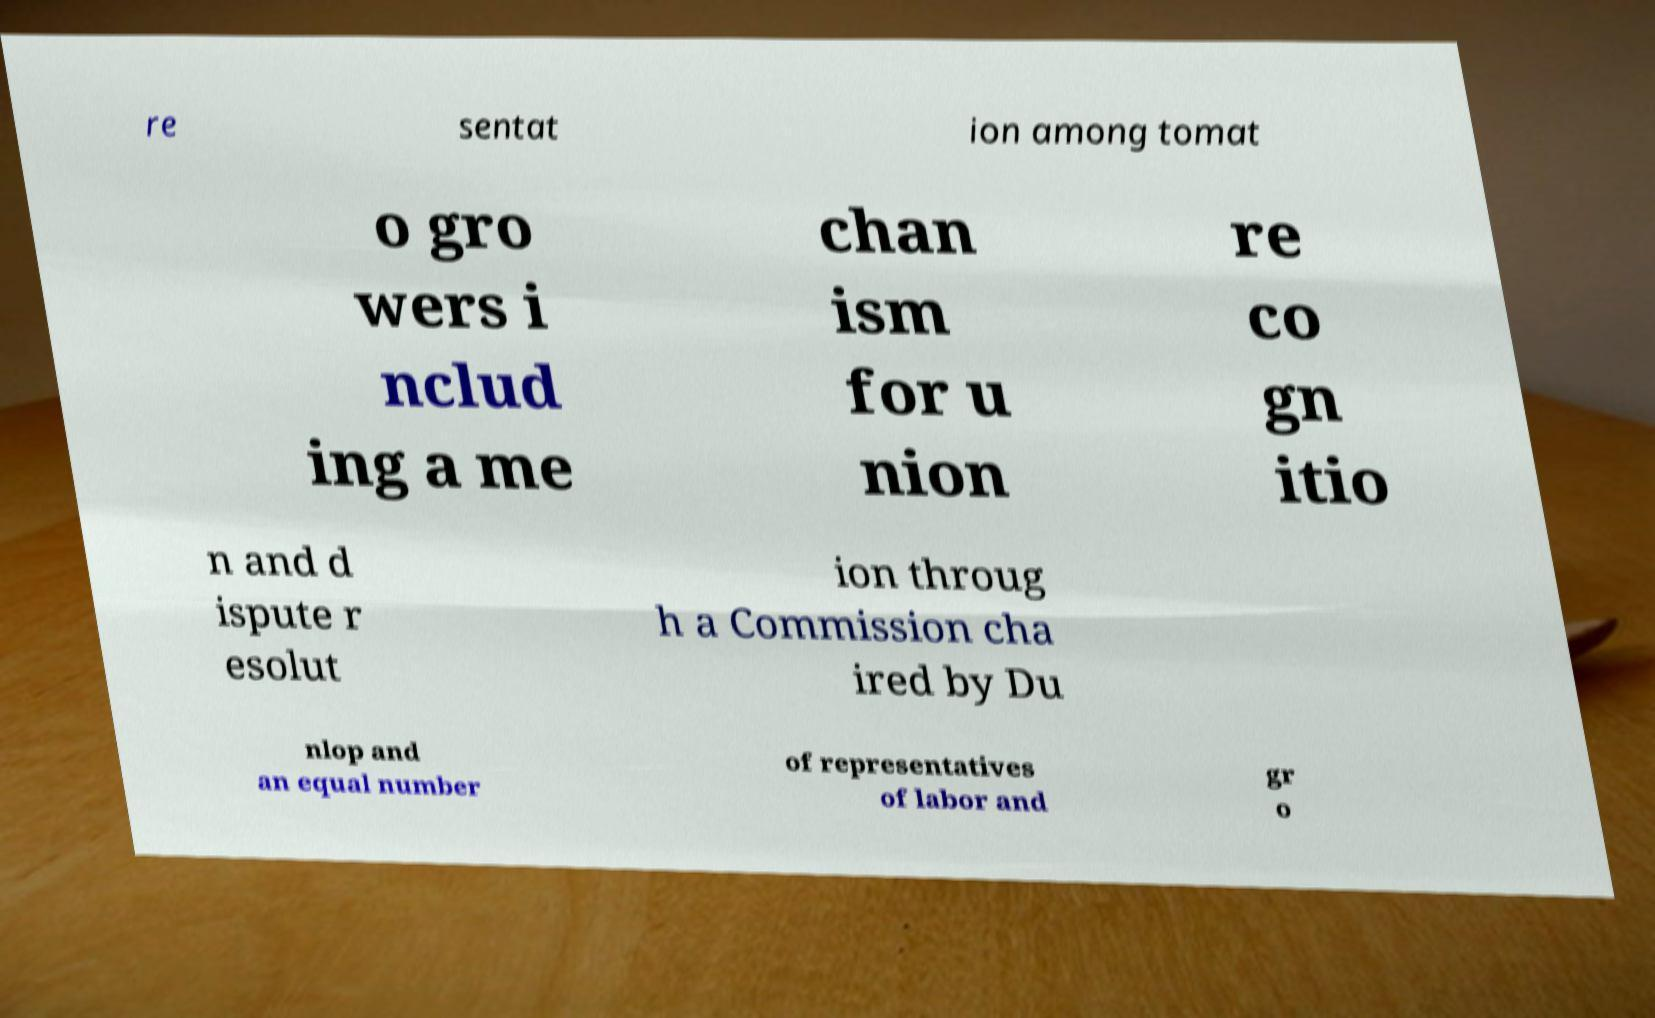Can you accurately transcribe the text from the provided image for me? re sentat ion among tomat o gro wers i nclud ing a me chan ism for u nion re co gn itio n and d ispute r esolut ion throug h a Commission cha ired by Du nlop and an equal number of representatives of labor and gr o 